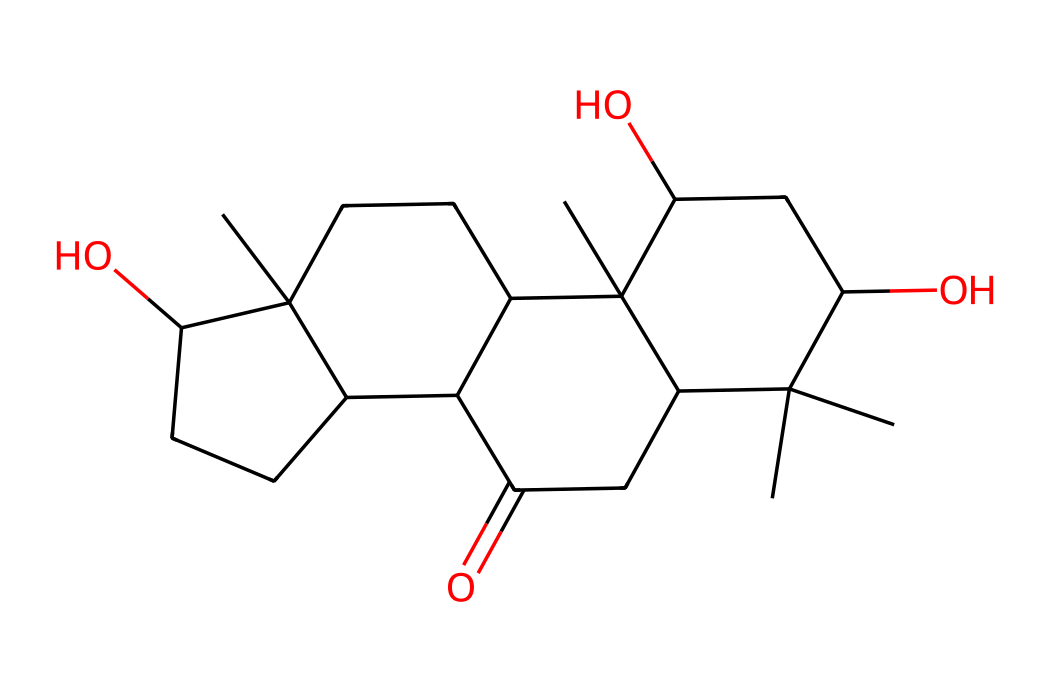What type of compound is represented by this SMILES? The SMILES refers to a structure that contains a hydroxyl group (–OH) indicating that it is an alcohol, and the presence of a carbonyl group (=O) suggests it could also have traits of a ketone; thus, it can be classified as a complex organic compound, likely with multiple functional groups.
Answer: complex organic compound How many carbon atoms are present in this structure? By analyzing the SMILES notation, we can count the number of "C" characters, which indicates the number of carbon atoms. In this case, there are a total of 15 carbon atoms in the structure.
Answer: 15 What is the primary functional group seen in this molecule? The SMILES notation shows the presence of a hydroxyl group (–OH) and a carbonyl group (–C=O). Since the hydroxyl group is more pronounced in many organic contexts, the primary functional group in this case is most likely the alcohol function.
Answer: alcohol What does the presence of the –OH group suggest about the solubility of this chemical? The –OH (hydroxyl) group enhances the polarity of the molecule, indicating that the compound is more likely to be soluble in water due to hydrogen bonding capabilities.
Answer: more water-soluble What could be a significant sensory characteristic of this liquid due to its chemical structure? The presence of multiple hydroxyl and carbonyl groups often leads to sweet or aromatic profiles in organic compounds; therefore, it is likely that this liquid has a sweet or rich flavor characteristic common in coffee oils.
Answer: sweet or rich flavor Does this structure indicate potential for aroma compounds? Yes, the presence of functional groups such as the carbonyl and hydroxyl suggests potential for volatile compounds which contribute to aroma; many aromatic compounds have similar functional groups.
Answer: yes, potential for aroma compounds What is a likely state of matter for this chemical at room temperature? Given that this structure includes several carbon atoms and functional groups found in many oils, it is reasonable to predict that this compound is a liquid at room temperature, as many oils are liquid under these conditions.
Answer: liquid 